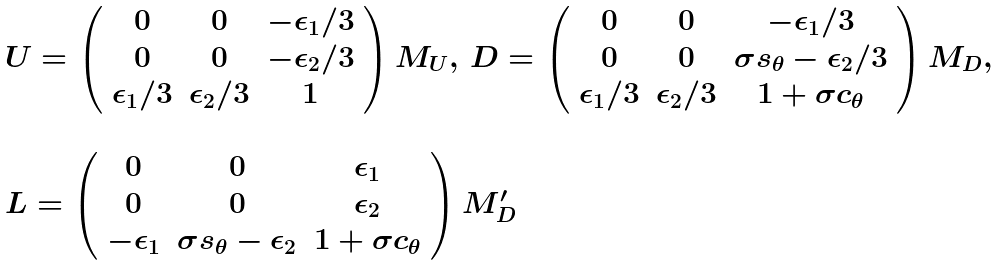Convert formula to latex. <formula><loc_0><loc_0><loc_500><loc_500>\begin{array} { l } U = \left ( \begin{array} { c c c } 0 & 0 & - \epsilon _ { 1 } / 3 \\ 0 & 0 & - \epsilon _ { 2 } / 3 \\ \epsilon _ { 1 } / 3 & \epsilon _ { 2 } / 3 & 1 \end{array} \right ) M _ { U } , \, D = \left ( \begin{array} { c c c } 0 & 0 & - \epsilon _ { 1 } / 3 \\ 0 & 0 & \sigma s _ { \theta } - \epsilon _ { 2 } / 3 \\ \epsilon _ { 1 } / 3 & \epsilon _ { 2 } / 3 & 1 + \sigma c _ { \theta } \end{array} \right ) M _ { D } , \\ \\ L = \left ( \begin{array} { c c c } 0 & 0 & \epsilon _ { 1 } \\ 0 & 0 & \epsilon _ { 2 } \\ - \epsilon _ { 1 } & \sigma s _ { \theta } - \epsilon _ { 2 } & 1 + \sigma c _ { \theta } \end{array} \right ) M _ { D } ^ { \prime } \end{array}</formula> 